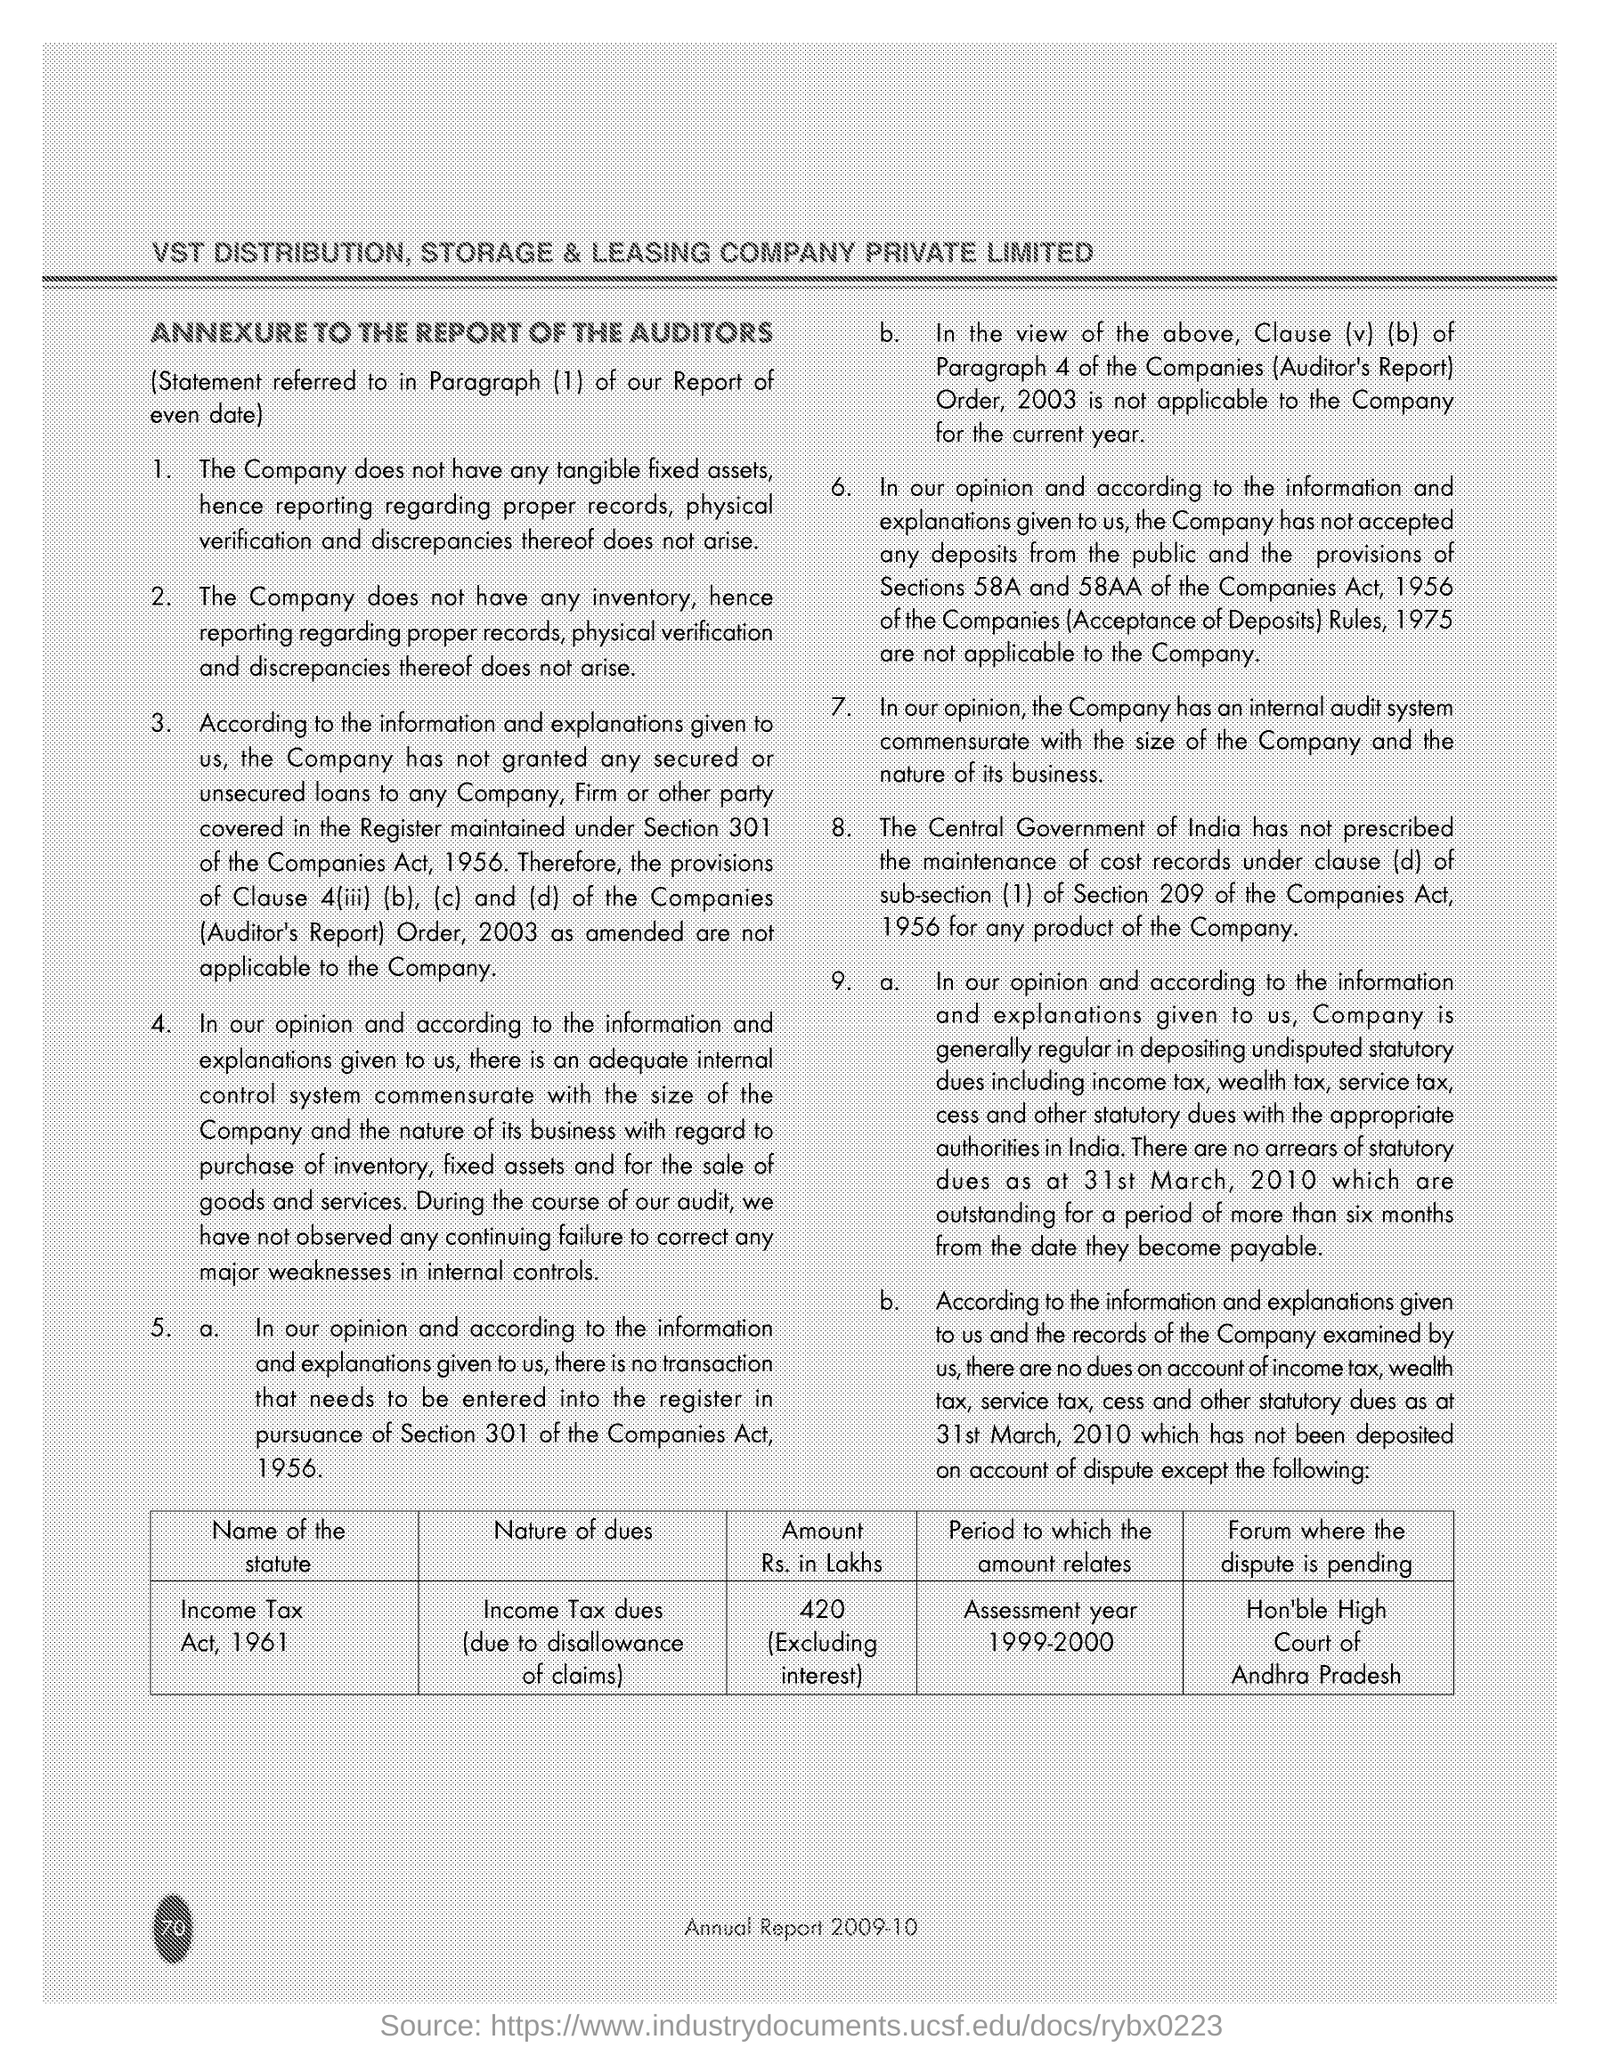Indicate a few pertinent items in this graphic. According to the page, the name of the Statute is the Income Tax Act, 1961. 